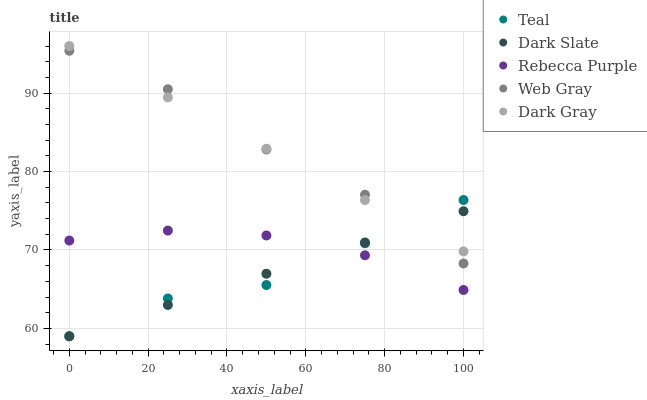Does Dark Slate have the minimum area under the curve?
Answer yes or no. Yes. Does Web Gray have the maximum area under the curve?
Answer yes or no. Yes. Does Web Gray have the minimum area under the curve?
Answer yes or no. No. Does Dark Slate have the maximum area under the curve?
Answer yes or no. No. Is Dark Slate the smoothest?
Answer yes or no. Yes. Is Web Gray the roughest?
Answer yes or no. Yes. Is Web Gray the smoothest?
Answer yes or no. No. Is Dark Slate the roughest?
Answer yes or no. No. Does Dark Slate have the lowest value?
Answer yes or no. Yes. Does Web Gray have the lowest value?
Answer yes or no. No. Does Dark Gray have the highest value?
Answer yes or no. Yes. Does Dark Slate have the highest value?
Answer yes or no. No. Is Rebecca Purple less than Web Gray?
Answer yes or no. Yes. Is Web Gray greater than Rebecca Purple?
Answer yes or no. Yes. Does Dark Gray intersect Web Gray?
Answer yes or no. Yes. Is Dark Gray less than Web Gray?
Answer yes or no. No. Is Dark Gray greater than Web Gray?
Answer yes or no. No. Does Rebecca Purple intersect Web Gray?
Answer yes or no. No. 